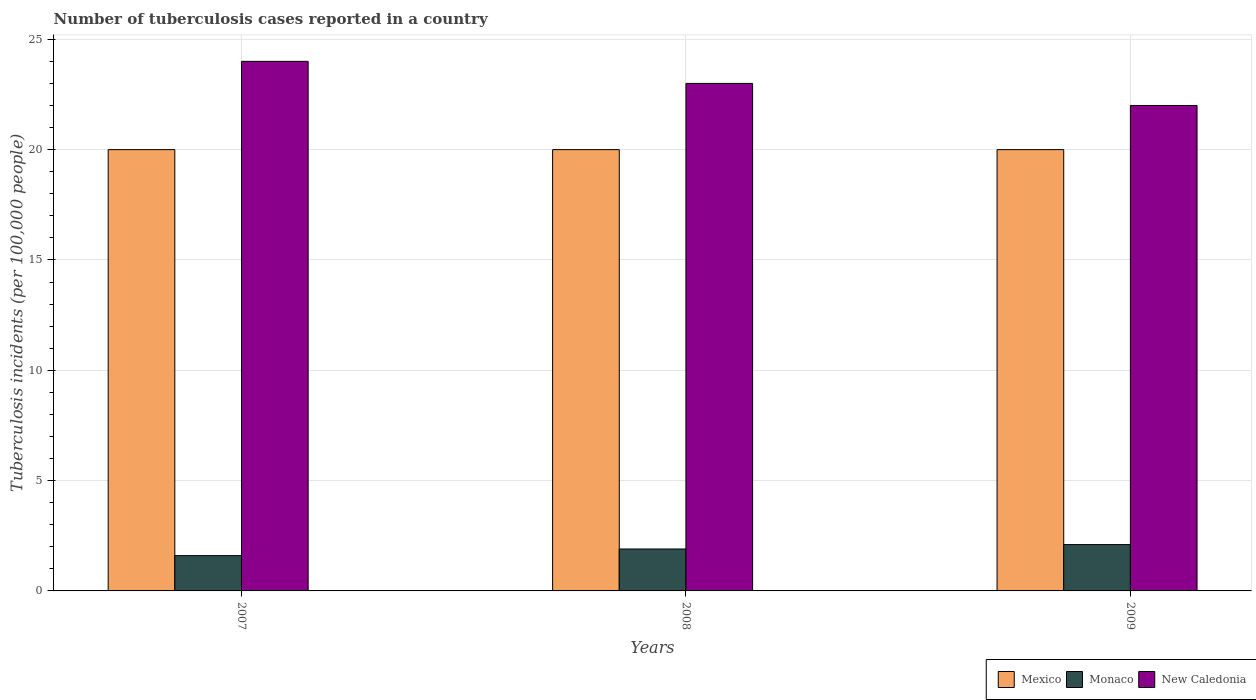How many different coloured bars are there?
Offer a terse response. 3. How many groups of bars are there?
Provide a short and direct response. 3. Are the number of bars per tick equal to the number of legend labels?
Offer a terse response. Yes. Are the number of bars on each tick of the X-axis equal?
Provide a short and direct response. Yes. How many bars are there on the 3rd tick from the right?
Your answer should be very brief. 3. What is the label of the 2nd group of bars from the left?
Ensure brevity in your answer.  2008. In how many cases, is the number of bars for a given year not equal to the number of legend labels?
Ensure brevity in your answer.  0. What is the number of tuberculosis cases reported in in New Caledonia in 2009?
Make the answer very short. 22. Across all years, what is the maximum number of tuberculosis cases reported in in New Caledonia?
Keep it short and to the point. 24. Across all years, what is the minimum number of tuberculosis cases reported in in Mexico?
Your answer should be compact. 20. What is the total number of tuberculosis cases reported in in New Caledonia in the graph?
Ensure brevity in your answer.  69. What is the difference between the number of tuberculosis cases reported in in New Caledonia in 2007 and the number of tuberculosis cases reported in in Monaco in 2008?
Your answer should be very brief. 22.1. In the year 2009, what is the difference between the number of tuberculosis cases reported in in Monaco and number of tuberculosis cases reported in in Mexico?
Ensure brevity in your answer.  -17.9. What is the difference between the highest and the second highest number of tuberculosis cases reported in in Monaco?
Keep it short and to the point. 0.2. What is the difference between the highest and the lowest number of tuberculosis cases reported in in New Caledonia?
Offer a very short reply. 2. What does the 2nd bar from the left in 2008 represents?
Provide a succinct answer. Monaco. What does the 1st bar from the right in 2009 represents?
Provide a short and direct response. New Caledonia. Is it the case that in every year, the sum of the number of tuberculosis cases reported in in Monaco and number of tuberculosis cases reported in in New Caledonia is greater than the number of tuberculosis cases reported in in Mexico?
Make the answer very short. Yes. Are the values on the major ticks of Y-axis written in scientific E-notation?
Your answer should be very brief. No. Does the graph contain any zero values?
Make the answer very short. No. Does the graph contain grids?
Your response must be concise. Yes. How many legend labels are there?
Ensure brevity in your answer.  3. How are the legend labels stacked?
Make the answer very short. Horizontal. What is the title of the graph?
Provide a short and direct response. Number of tuberculosis cases reported in a country. What is the label or title of the X-axis?
Offer a terse response. Years. What is the label or title of the Y-axis?
Your answer should be very brief. Tuberculosis incidents (per 100,0 people). What is the Tuberculosis incidents (per 100,000 people) of New Caledonia in 2007?
Make the answer very short. 24. What is the Tuberculosis incidents (per 100,000 people) in Mexico in 2008?
Make the answer very short. 20. What is the Tuberculosis incidents (per 100,000 people) in Mexico in 2009?
Ensure brevity in your answer.  20. What is the Tuberculosis incidents (per 100,000 people) in Monaco in 2009?
Make the answer very short. 2.1. What is the Tuberculosis incidents (per 100,000 people) of New Caledonia in 2009?
Provide a short and direct response. 22. Across all years, what is the maximum Tuberculosis incidents (per 100,000 people) of Monaco?
Offer a terse response. 2.1. Across all years, what is the maximum Tuberculosis incidents (per 100,000 people) of New Caledonia?
Offer a terse response. 24. Across all years, what is the minimum Tuberculosis incidents (per 100,000 people) in Mexico?
Give a very brief answer. 20. Across all years, what is the minimum Tuberculosis incidents (per 100,000 people) in Monaco?
Your response must be concise. 1.6. Across all years, what is the minimum Tuberculosis incidents (per 100,000 people) in New Caledonia?
Make the answer very short. 22. What is the difference between the Tuberculosis incidents (per 100,000 people) of Mexico in 2007 and that in 2008?
Offer a terse response. 0. What is the difference between the Tuberculosis incidents (per 100,000 people) in New Caledonia in 2007 and that in 2008?
Keep it short and to the point. 1. What is the difference between the Tuberculosis incidents (per 100,000 people) of Mexico in 2007 and that in 2009?
Provide a short and direct response. 0. What is the difference between the Tuberculosis incidents (per 100,000 people) of Monaco in 2007 and that in 2009?
Your answer should be very brief. -0.5. What is the difference between the Tuberculosis incidents (per 100,000 people) in New Caledonia in 2007 and that in 2009?
Your answer should be very brief. 2. What is the difference between the Tuberculosis incidents (per 100,000 people) of New Caledonia in 2008 and that in 2009?
Provide a succinct answer. 1. What is the difference between the Tuberculosis incidents (per 100,000 people) in Mexico in 2007 and the Tuberculosis incidents (per 100,000 people) in Monaco in 2008?
Ensure brevity in your answer.  18.1. What is the difference between the Tuberculosis incidents (per 100,000 people) in Mexico in 2007 and the Tuberculosis incidents (per 100,000 people) in New Caledonia in 2008?
Give a very brief answer. -3. What is the difference between the Tuberculosis incidents (per 100,000 people) in Monaco in 2007 and the Tuberculosis incidents (per 100,000 people) in New Caledonia in 2008?
Offer a terse response. -21.4. What is the difference between the Tuberculosis incidents (per 100,000 people) of Mexico in 2007 and the Tuberculosis incidents (per 100,000 people) of New Caledonia in 2009?
Offer a terse response. -2. What is the difference between the Tuberculosis incidents (per 100,000 people) of Monaco in 2007 and the Tuberculosis incidents (per 100,000 people) of New Caledonia in 2009?
Give a very brief answer. -20.4. What is the difference between the Tuberculosis incidents (per 100,000 people) in Mexico in 2008 and the Tuberculosis incidents (per 100,000 people) in Monaco in 2009?
Provide a short and direct response. 17.9. What is the difference between the Tuberculosis incidents (per 100,000 people) in Mexico in 2008 and the Tuberculosis incidents (per 100,000 people) in New Caledonia in 2009?
Provide a short and direct response. -2. What is the difference between the Tuberculosis incidents (per 100,000 people) in Monaco in 2008 and the Tuberculosis incidents (per 100,000 people) in New Caledonia in 2009?
Make the answer very short. -20.1. What is the average Tuberculosis incidents (per 100,000 people) in Mexico per year?
Your response must be concise. 20. What is the average Tuberculosis incidents (per 100,000 people) of Monaco per year?
Ensure brevity in your answer.  1.87. In the year 2007, what is the difference between the Tuberculosis incidents (per 100,000 people) in Mexico and Tuberculosis incidents (per 100,000 people) in Monaco?
Provide a succinct answer. 18.4. In the year 2007, what is the difference between the Tuberculosis incidents (per 100,000 people) of Mexico and Tuberculosis incidents (per 100,000 people) of New Caledonia?
Provide a succinct answer. -4. In the year 2007, what is the difference between the Tuberculosis incidents (per 100,000 people) of Monaco and Tuberculosis incidents (per 100,000 people) of New Caledonia?
Ensure brevity in your answer.  -22.4. In the year 2008, what is the difference between the Tuberculosis incidents (per 100,000 people) of Monaco and Tuberculosis incidents (per 100,000 people) of New Caledonia?
Provide a succinct answer. -21.1. In the year 2009, what is the difference between the Tuberculosis incidents (per 100,000 people) in Mexico and Tuberculosis incidents (per 100,000 people) in New Caledonia?
Your answer should be very brief. -2. In the year 2009, what is the difference between the Tuberculosis incidents (per 100,000 people) of Monaco and Tuberculosis incidents (per 100,000 people) of New Caledonia?
Provide a short and direct response. -19.9. What is the ratio of the Tuberculosis incidents (per 100,000 people) of Mexico in 2007 to that in 2008?
Offer a terse response. 1. What is the ratio of the Tuberculosis incidents (per 100,000 people) of Monaco in 2007 to that in 2008?
Provide a succinct answer. 0.84. What is the ratio of the Tuberculosis incidents (per 100,000 people) of New Caledonia in 2007 to that in 2008?
Give a very brief answer. 1.04. What is the ratio of the Tuberculosis incidents (per 100,000 people) in Mexico in 2007 to that in 2009?
Your answer should be compact. 1. What is the ratio of the Tuberculosis incidents (per 100,000 people) in Monaco in 2007 to that in 2009?
Provide a succinct answer. 0.76. What is the ratio of the Tuberculosis incidents (per 100,000 people) of New Caledonia in 2007 to that in 2009?
Offer a very short reply. 1.09. What is the ratio of the Tuberculosis incidents (per 100,000 people) in Monaco in 2008 to that in 2009?
Offer a very short reply. 0.9. What is the ratio of the Tuberculosis incidents (per 100,000 people) in New Caledonia in 2008 to that in 2009?
Provide a succinct answer. 1.05. What is the difference between the highest and the second highest Tuberculosis incidents (per 100,000 people) in Mexico?
Keep it short and to the point. 0. What is the difference between the highest and the second highest Tuberculosis incidents (per 100,000 people) in Monaco?
Your response must be concise. 0.2. What is the difference between the highest and the lowest Tuberculosis incidents (per 100,000 people) in Mexico?
Offer a terse response. 0. What is the difference between the highest and the lowest Tuberculosis incidents (per 100,000 people) of Monaco?
Offer a very short reply. 0.5. What is the difference between the highest and the lowest Tuberculosis incidents (per 100,000 people) of New Caledonia?
Give a very brief answer. 2. 